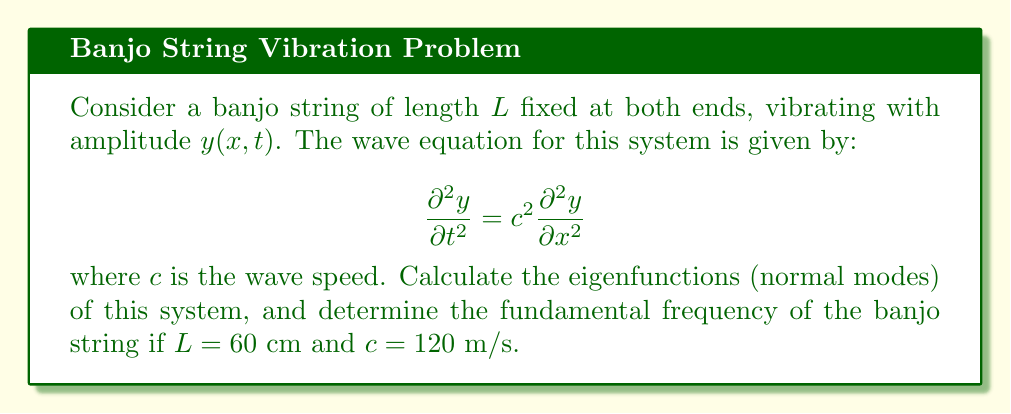Could you help me with this problem? To solve this problem, we'll follow these steps:

1) The eigenfunctions (normal modes) of a vibrating string fixed at both ends are given by:

   $$y_n(x) = A_n \sin(\frac{n\pi x}{L})$$

   where $n = 1, 2, 3, ...$ and $A_n$ is the amplitude of the $n$-th mode.

2) These eigenfunctions satisfy the boundary conditions $y(0) = y(L) = 0$.

3) The corresponding eigenfrequencies are:

   $$f_n = \frac{nc}{2L}$$

4) The fundamental frequency is the lowest frequency, which occurs when $n = 1$:

   $$f_1 = \frac{c}{2L}$$

5) Substituting the given values:
   $L = 60$ cm $= 0.6$ m
   $c = 120$ m/s

   $$f_1 = \frac{120}{2(0.6)} = 100 \text{ Hz}$$

Therefore, the fundamental frequency of the banjo string is 100 Hz.
Answer: Eigenfunctions: $y_n(x) = A_n \sin(\frac{n\pi x}{L})$; Fundamental frequency: 100 Hz 